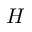Convert formula to latex. <formula><loc_0><loc_0><loc_500><loc_500>H</formula> 